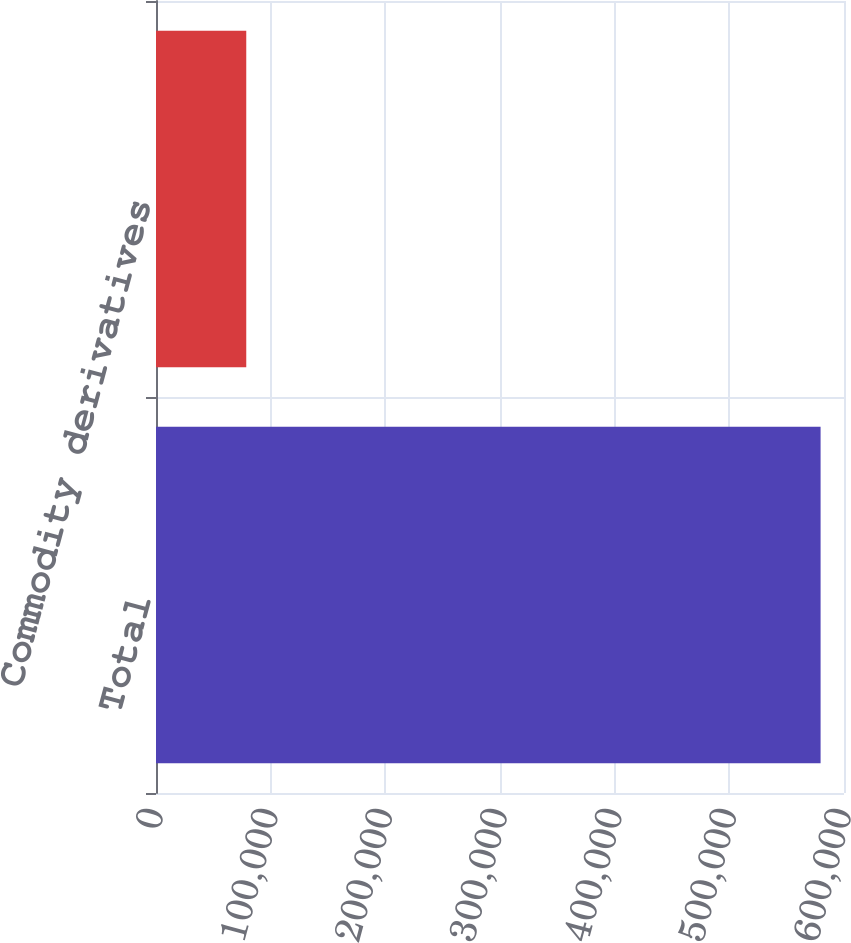Convert chart. <chart><loc_0><loc_0><loc_500><loc_500><bar_chart><fcel>Total<fcel>Commodity derivatives<nl><fcel>579583<fcel>78714<nl></chart> 